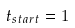Convert formula to latex. <formula><loc_0><loc_0><loc_500><loc_500>t _ { s t a r t } = 1</formula> 